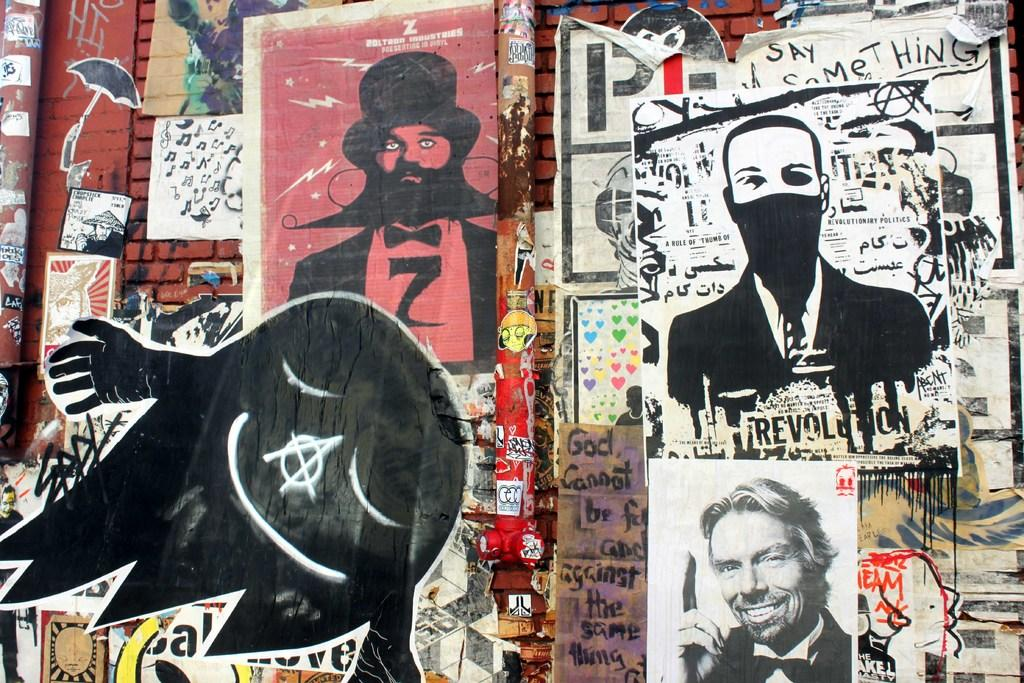What types of artwork can be seen on the wall in the image? There are photographs, paintings, and stickers on the wall. Can you describe the different types of artwork in more detail? The photographs are likely images captured on film or digitally, the paintings are likely created using paint or other pigments, and the stickers are likely adhesive-backed images or designs. What type of crayon is being used to draw on the wall in the image? There is no crayon or drawing on the wall in the image; it only features photographs, paintings, and stickers. 